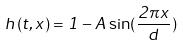Convert formula to latex. <formula><loc_0><loc_0><loc_500><loc_500>h ( t , x ) = 1 - A \sin ( \frac { 2 \pi x } { d } )</formula> 